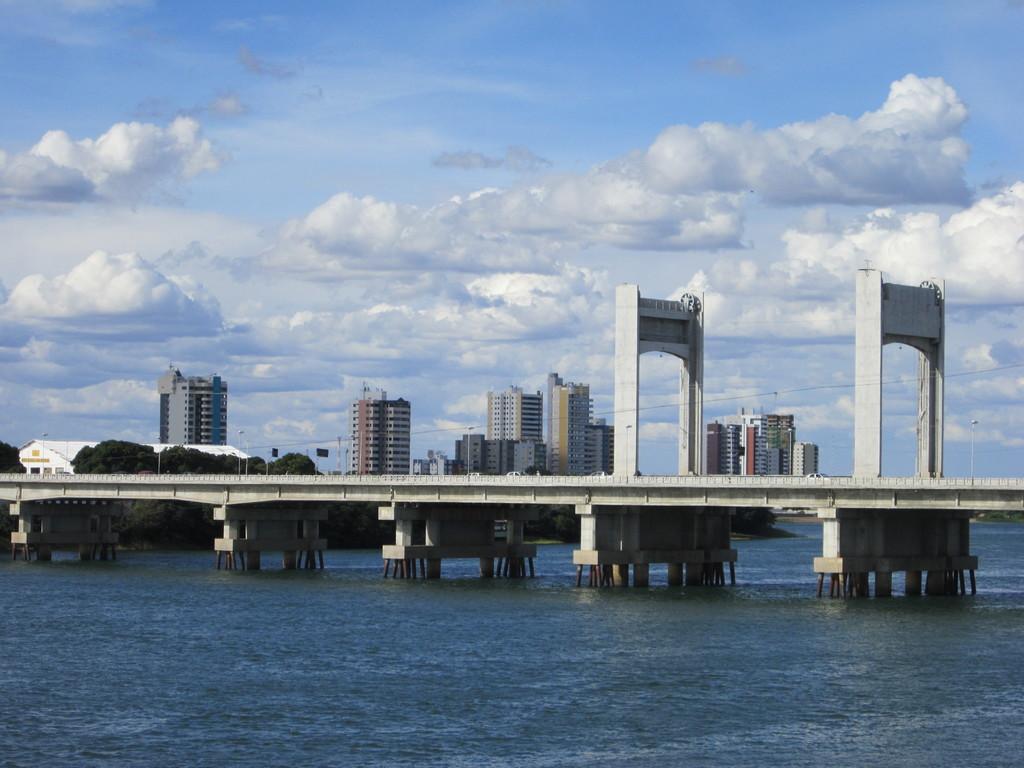Can you describe this image briefly? This image is taken outdoors. At the bottom of the image there is a sea. At the top of the image there is a sky with clouds. In the middle of the image there is a bridge with pillars and iron bars. In the background there are many buildings with walls, windows, doors and roofs. There are a few trees. 